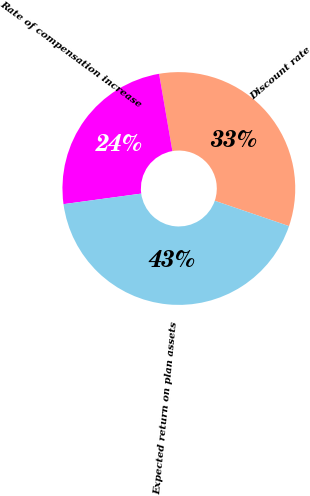Convert chart to OTSL. <chart><loc_0><loc_0><loc_500><loc_500><pie_chart><fcel>Discount rate<fcel>Rate of compensation increase<fcel>Expected return on plan assets<nl><fcel>32.95%<fcel>24.43%<fcel>42.61%<nl></chart> 